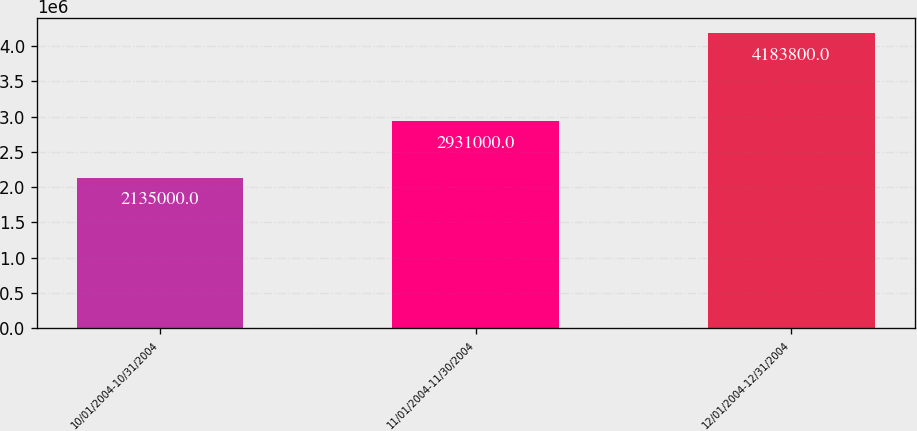<chart> <loc_0><loc_0><loc_500><loc_500><bar_chart><fcel>10/01/2004-10/31/2004<fcel>11/01/2004-11/30/2004<fcel>12/01/2004-12/31/2004<nl><fcel>2.135e+06<fcel>2.931e+06<fcel>4.1838e+06<nl></chart> 